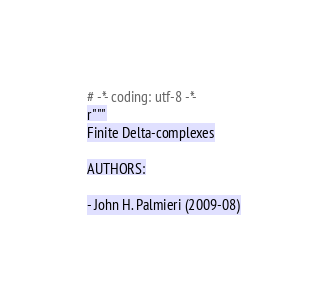<code> <loc_0><loc_0><loc_500><loc_500><_Python_># -*- coding: utf-8 -*-
r"""
Finite Delta-complexes

AUTHORS:

- John H. Palmieri (2009-08)
</code> 